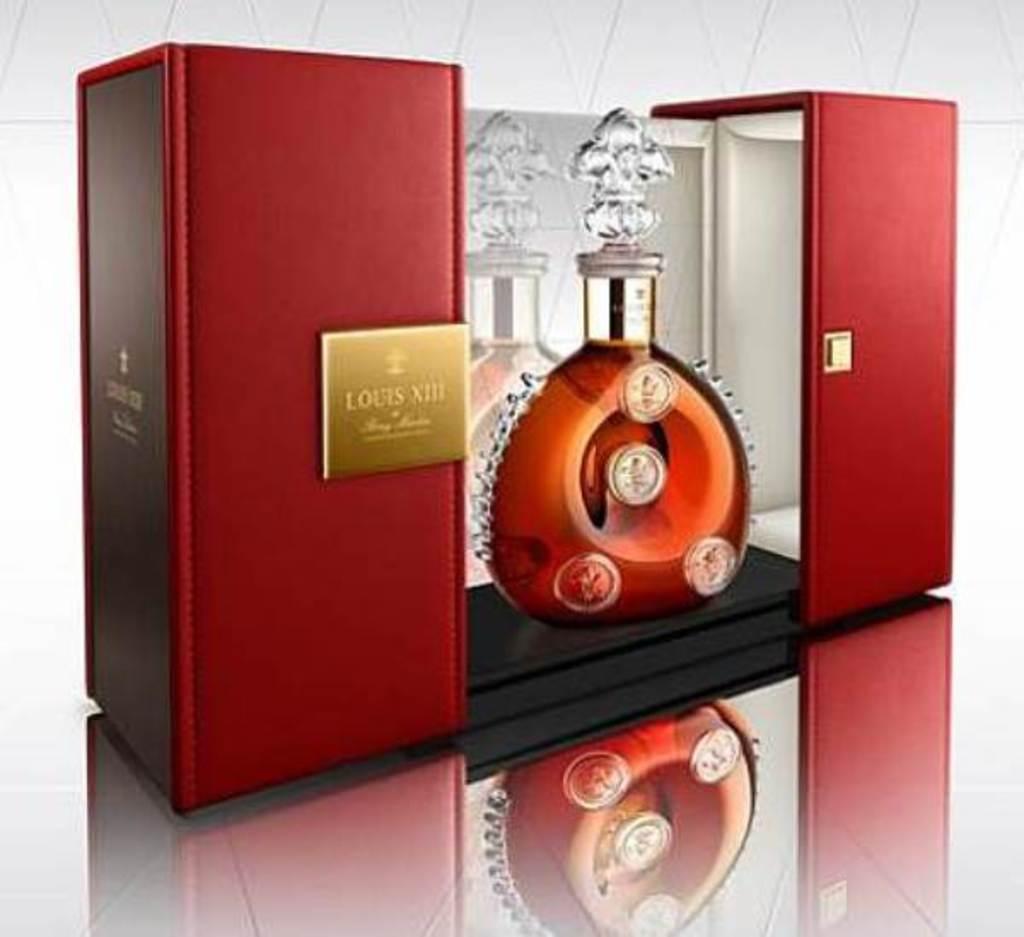What are the roman numerals on the box?
Keep it short and to the point. Xiii. 